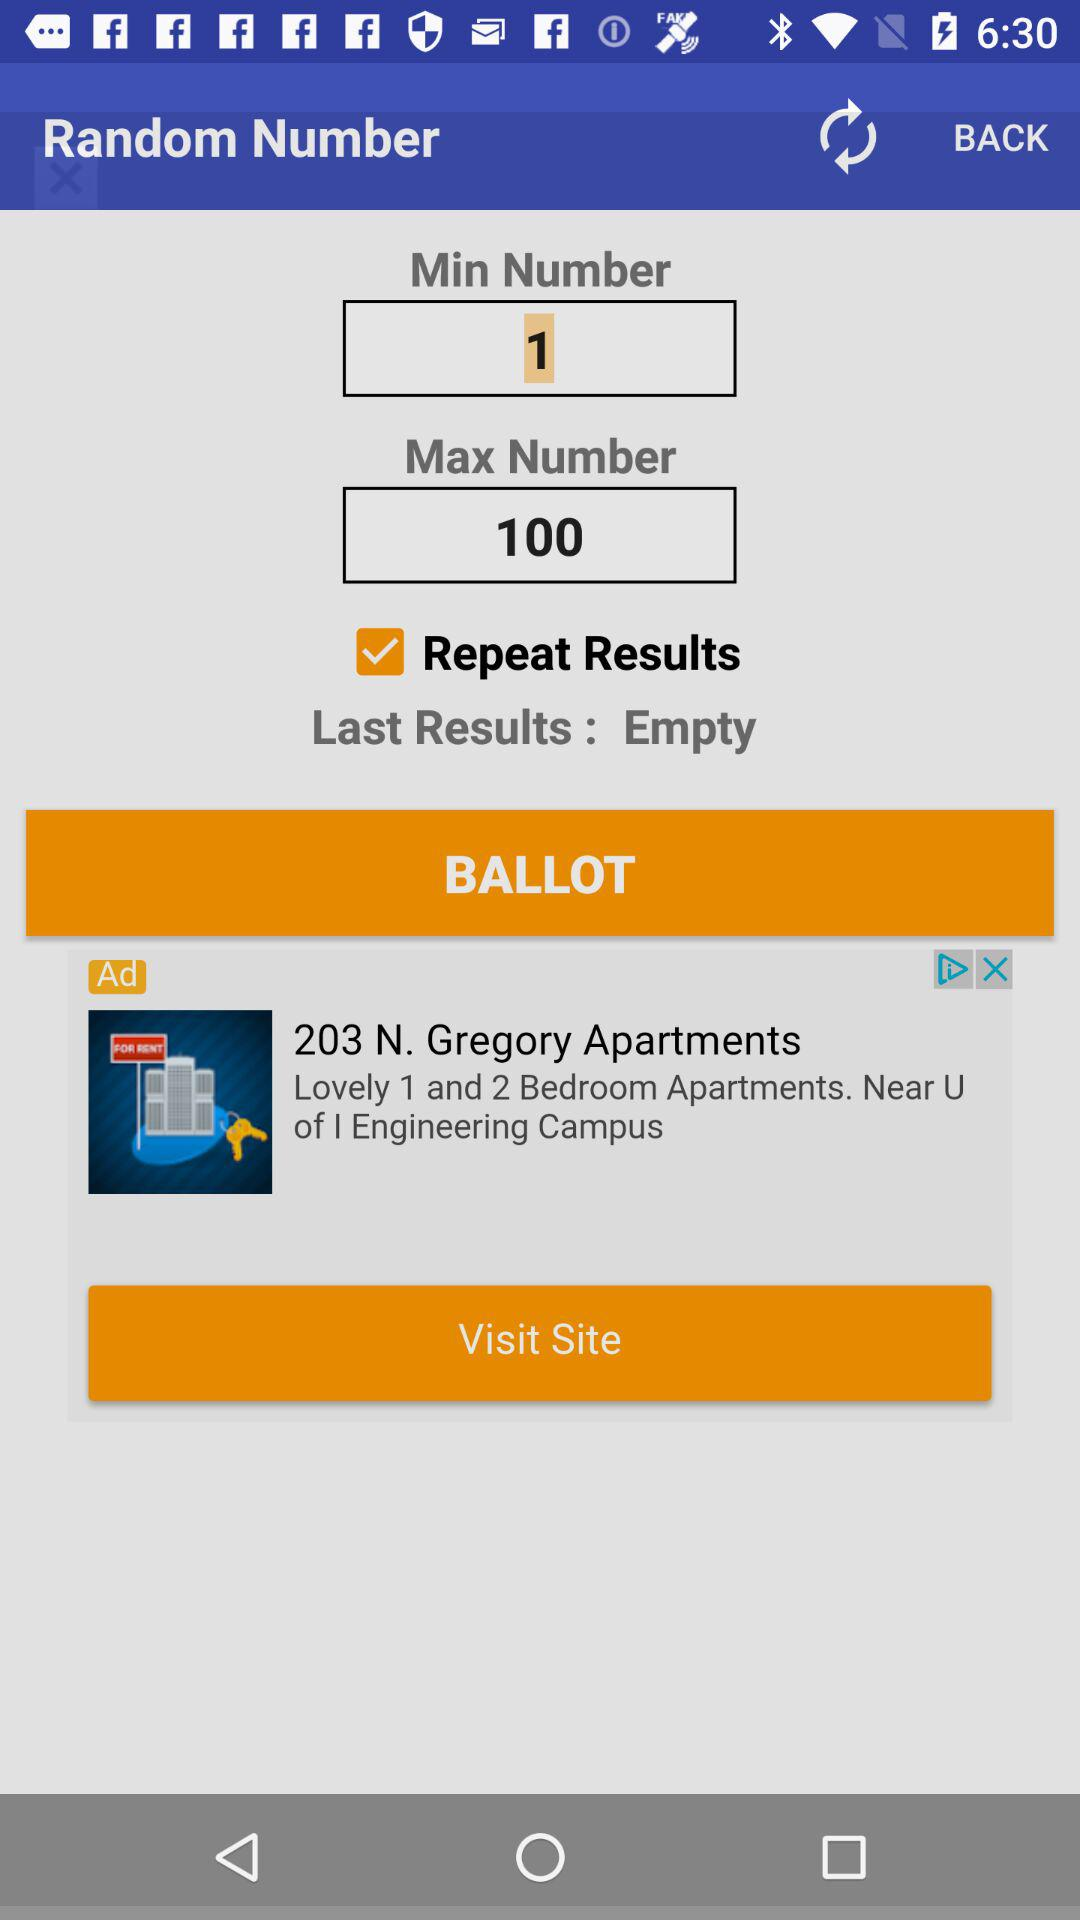What are the last results? The last results are "Empty". 